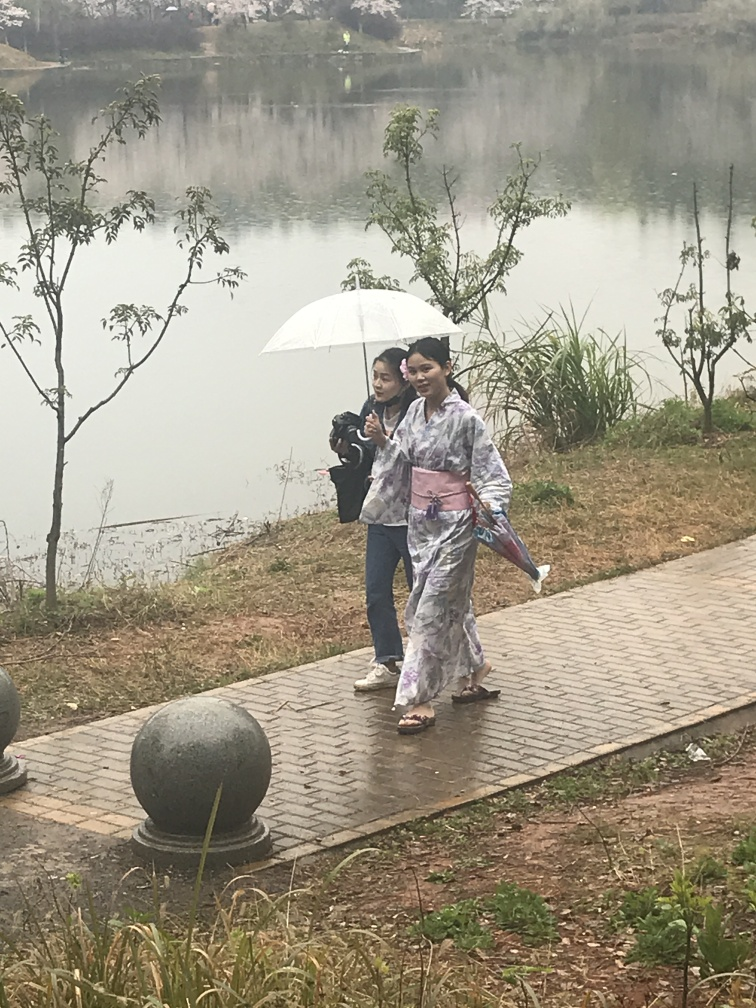Can you tell me more about the style of clothing worn by the person in the image? Certainly! The person is wearing a traditional kimono, which is characterized by its T-shaped, straight-lined robes worn so that the hem falls to the ankle, with long, wide sleeves and a collar. The kimono is traditionally worn with an obi, and is often seen during special occasions in Japan. 